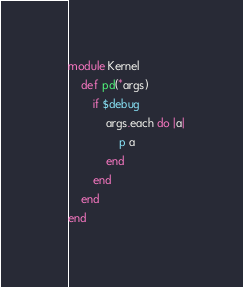<code> <loc_0><loc_0><loc_500><loc_500><_Ruby_>module Kernel
	def pd(*args)
		if $debug
			args.each do |a|
				p a
			end
		end
	end
end</code> 